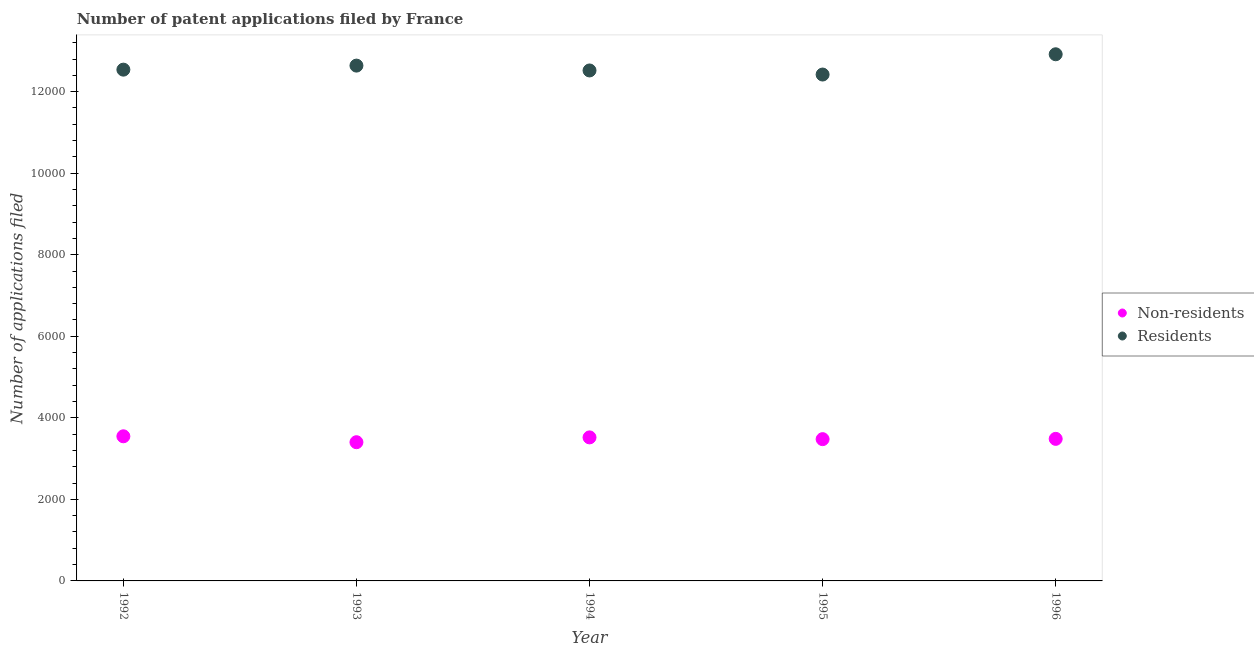How many different coloured dotlines are there?
Offer a terse response. 2. Is the number of dotlines equal to the number of legend labels?
Make the answer very short. Yes. What is the number of patent applications by residents in 1996?
Your answer should be very brief. 1.29e+04. Across all years, what is the maximum number of patent applications by non residents?
Offer a terse response. 3547. Across all years, what is the minimum number of patent applications by residents?
Provide a succinct answer. 1.24e+04. In which year was the number of patent applications by non residents maximum?
Provide a succinct answer. 1992. In which year was the number of patent applications by residents minimum?
Offer a very short reply. 1995. What is the total number of patent applications by residents in the graph?
Provide a short and direct response. 6.30e+04. What is the difference between the number of patent applications by non residents in 1992 and that in 1996?
Your answer should be compact. 63. What is the difference between the number of patent applications by residents in 1996 and the number of patent applications by non residents in 1992?
Make the answer very short. 9369. What is the average number of patent applications by non residents per year?
Make the answer very short. 3486. In the year 1994, what is the difference between the number of patent applications by residents and number of patent applications by non residents?
Provide a succinct answer. 8999. In how many years, is the number of patent applications by residents greater than 12800?
Give a very brief answer. 1. What is the ratio of the number of patent applications by non residents in 1995 to that in 1996?
Make the answer very short. 1. What is the difference between the highest and the second highest number of patent applications by residents?
Your answer should be compact. 278. What is the difference between the highest and the lowest number of patent applications by residents?
Offer a terse response. 497. In how many years, is the number of patent applications by non residents greater than the average number of patent applications by non residents taken over all years?
Give a very brief answer. 2. Is the sum of the number of patent applications by residents in 1995 and 1996 greater than the maximum number of patent applications by non residents across all years?
Keep it short and to the point. Yes. Does the number of patent applications by residents monotonically increase over the years?
Keep it short and to the point. No. Is the number of patent applications by residents strictly greater than the number of patent applications by non residents over the years?
Make the answer very short. Yes. Are the values on the major ticks of Y-axis written in scientific E-notation?
Offer a very short reply. No. Does the graph contain grids?
Keep it short and to the point. No. Where does the legend appear in the graph?
Ensure brevity in your answer.  Center right. How many legend labels are there?
Keep it short and to the point. 2. How are the legend labels stacked?
Keep it short and to the point. Vertical. What is the title of the graph?
Make the answer very short. Number of patent applications filed by France. What is the label or title of the X-axis?
Your response must be concise. Year. What is the label or title of the Y-axis?
Provide a short and direct response. Number of applications filed. What is the Number of applications filed of Non-residents in 1992?
Provide a succinct answer. 3547. What is the Number of applications filed in Residents in 1992?
Make the answer very short. 1.25e+04. What is the Number of applications filed of Non-residents in 1993?
Provide a short and direct response. 3402. What is the Number of applications filed in Residents in 1993?
Ensure brevity in your answer.  1.26e+04. What is the Number of applications filed in Non-residents in 1994?
Provide a short and direct response. 3520. What is the Number of applications filed in Residents in 1994?
Give a very brief answer. 1.25e+04. What is the Number of applications filed of Non-residents in 1995?
Your response must be concise. 3477. What is the Number of applications filed of Residents in 1995?
Your answer should be very brief. 1.24e+04. What is the Number of applications filed in Non-residents in 1996?
Give a very brief answer. 3484. What is the Number of applications filed in Residents in 1996?
Ensure brevity in your answer.  1.29e+04. Across all years, what is the maximum Number of applications filed of Non-residents?
Offer a very short reply. 3547. Across all years, what is the maximum Number of applications filed in Residents?
Make the answer very short. 1.29e+04. Across all years, what is the minimum Number of applications filed in Non-residents?
Provide a short and direct response. 3402. Across all years, what is the minimum Number of applications filed in Residents?
Provide a succinct answer. 1.24e+04. What is the total Number of applications filed of Non-residents in the graph?
Provide a short and direct response. 1.74e+04. What is the total Number of applications filed of Residents in the graph?
Make the answer very short. 6.30e+04. What is the difference between the Number of applications filed of Non-residents in 1992 and that in 1993?
Your response must be concise. 145. What is the difference between the Number of applications filed in Residents in 1992 and that in 1993?
Provide a short and direct response. -99. What is the difference between the Number of applications filed of Residents in 1992 and that in 1994?
Keep it short and to the point. 20. What is the difference between the Number of applications filed in Non-residents in 1992 and that in 1995?
Give a very brief answer. 70. What is the difference between the Number of applications filed of Residents in 1992 and that in 1995?
Keep it short and to the point. 120. What is the difference between the Number of applications filed of Non-residents in 1992 and that in 1996?
Provide a short and direct response. 63. What is the difference between the Number of applications filed in Residents in 1992 and that in 1996?
Ensure brevity in your answer.  -377. What is the difference between the Number of applications filed of Non-residents in 1993 and that in 1994?
Offer a very short reply. -118. What is the difference between the Number of applications filed of Residents in 1993 and that in 1994?
Your response must be concise. 119. What is the difference between the Number of applications filed in Non-residents in 1993 and that in 1995?
Make the answer very short. -75. What is the difference between the Number of applications filed in Residents in 1993 and that in 1995?
Offer a terse response. 219. What is the difference between the Number of applications filed of Non-residents in 1993 and that in 1996?
Give a very brief answer. -82. What is the difference between the Number of applications filed in Residents in 1993 and that in 1996?
Your response must be concise. -278. What is the difference between the Number of applications filed of Non-residents in 1994 and that in 1995?
Your response must be concise. 43. What is the difference between the Number of applications filed in Non-residents in 1994 and that in 1996?
Your answer should be compact. 36. What is the difference between the Number of applications filed in Residents in 1994 and that in 1996?
Keep it short and to the point. -397. What is the difference between the Number of applications filed of Residents in 1995 and that in 1996?
Provide a short and direct response. -497. What is the difference between the Number of applications filed of Non-residents in 1992 and the Number of applications filed of Residents in 1993?
Provide a short and direct response. -9091. What is the difference between the Number of applications filed of Non-residents in 1992 and the Number of applications filed of Residents in 1994?
Offer a very short reply. -8972. What is the difference between the Number of applications filed in Non-residents in 1992 and the Number of applications filed in Residents in 1995?
Your answer should be very brief. -8872. What is the difference between the Number of applications filed of Non-residents in 1992 and the Number of applications filed of Residents in 1996?
Your answer should be very brief. -9369. What is the difference between the Number of applications filed in Non-residents in 1993 and the Number of applications filed in Residents in 1994?
Give a very brief answer. -9117. What is the difference between the Number of applications filed in Non-residents in 1993 and the Number of applications filed in Residents in 1995?
Offer a terse response. -9017. What is the difference between the Number of applications filed of Non-residents in 1993 and the Number of applications filed of Residents in 1996?
Your response must be concise. -9514. What is the difference between the Number of applications filed of Non-residents in 1994 and the Number of applications filed of Residents in 1995?
Your answer should be compact. -8899. What is the difference between the Number of applications filed in Non-residents in 1994 and the Number of applications filed in Residents in 1996?
Your answer should be very brief. -9396. What is the difference between the Number of applications filed in Non-residents in 1995 and the Number of applications filed in Residents in 1996?
Make the answer very short. -9439. What is the average Number of applications filed in Non-residents per year?
Give a very brief answer. 3486. What is the average Number of applications filed in Residents per year?
Keep it short and to the point. 1.26e+04. In the year 1992, what is the difference between the Number of applications filed in Non-residents and Number of applications filed in Residents?
Keep it short and to the point. -8992. In the year 1993, what is the difference between the Number of applications filed of Non-residents and Number of applications filed of Residents?
Keep it short and to the point. -9236. In the year 1994, what is the difference between the Number of applications filed of Non-residents and Number of applications filed of Residents?
Offer a terse response. -8999. In the year 1995, what is the difference between the Number of applications filed of Non-residents and Number of applications filed of Residents?
Keep it short and to the point. -8942. In the year 1996, what is the difference between the Number of applications filed of Non-residents and Number of applications filed of Residents?
Give a very brief answer. -9432. What is the ratio of the Number of applications filed in Non-residents in 1992 to that in 1993?
Your answer should be compact. 1.04. What is the ratio of the Number of applications filed of Non-residents in 1992 to that in 1994?
Provide a short and direct response. 1.01. What is the ratio of the Number of applications filed in Non-residents in 1992 to that in 1995?
Ensure brevity in your answer.  1.02. What is the ratio of the Number of applications filed in Residents in 1992 to that in 1995?
Your answer should be very brief. 1.01. What is the ratio of the Number of applications filed in Non-residents in 1992 to that in 1996?
Provide a short and direct response. 1.02. What is the ratio of the Number of applications filed of Residents in 1992 to that in 1996?
Your answer should be very brief. 0.97. What is the ratio of the Number of applications filed in Non-residents in 1993 to that in 1994?
Offer a terse response. 0.97. What is the ratio of the Number of applications filed in Residents in 1993 to that in 1994?
Your answer should be compact. 1.01. What is the ratio of the Number of applications filed of Non-residents in 1993 to that in 1995?
Ensure brevity in your answer.  0.98. What is the ratio of the Number of applications filed in Residents in 1993 to that in 1995?
Give a very brief answer. 1.02. What is the ratio of the Number of applications filed in Non-residents in 1993 to that in 1996?
Provide a succinct answer. 0.98. What is the ratio of the Number of applications filed in Residents in 1993 to that in 1996?
Keep it short and to the point. 0.98. What is the ratio of the Number of applications filed of Non-residents in 1994 to that in 1995?
Provide a succinct answer. 1.01. What is the ratio of the Number of applications filed of Non-residents in 1994 to that in 1996?
Provide a short and direct response. 1.01. What is the ratio of the Number of applications filed in Residents in 1994 to that in 1996?
Your answer should be compact. 0.97. What is the ratio of the Number of applications filed in Residents in 1995 to that in 1996?
Make the answer very short. 0.96. What is the difference between the highest and the second highest Number of applications filed of Residents?
Your answer should be compact. 278. What is the difference between the highest and the lowest Number of applications filed of Non-residents?
Your answer should be very brief. 145. What is the difference between the highest and the lowest Number of applications filed of Residents?
Offer a terse response. 497. 